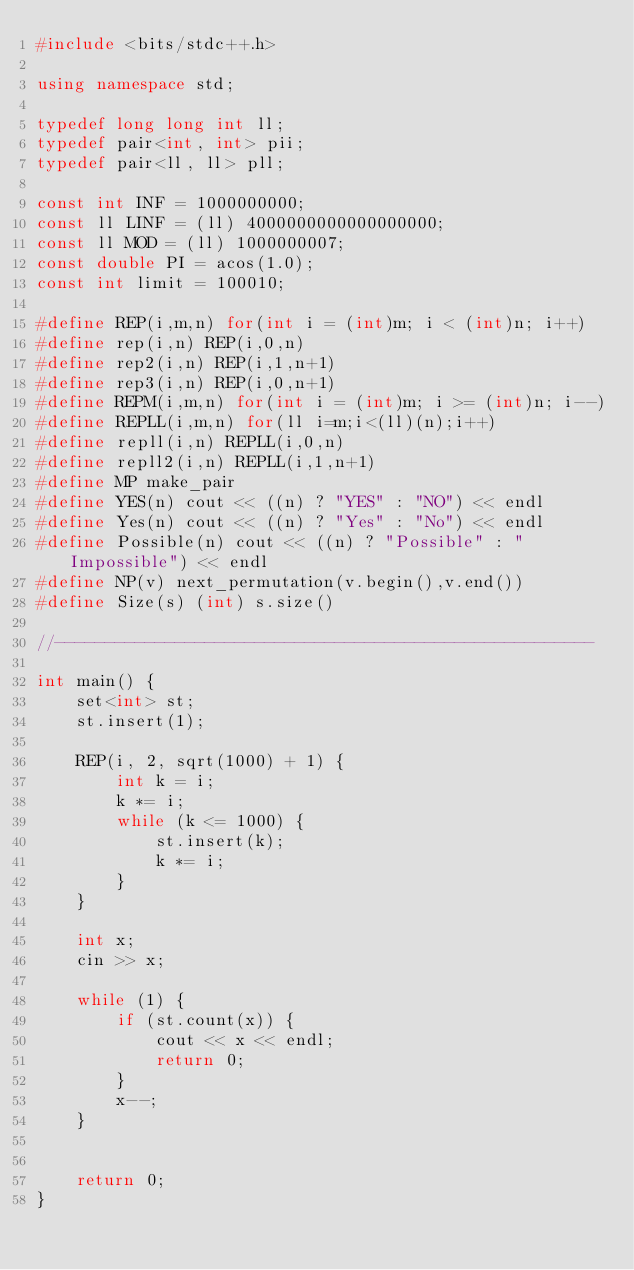Convert code to text. <code><loc_0><loc_0><loc_500><loc_500><_C++_>#include <bits/stdc++.h>

using namespace std;

typedef long long int ll;
typedef pair<int, int> pii;
typedef pair<ll, ll> pll;

const int INF = 1000000000;
const ll LINF = (ll) 4000000000000000000;
const ll MOD = (ll) 1000000007;
const double PI = acos(1.0);
const int limit = 100010;

#define REP(i,m,n) for(int i = (int)m; i < (int)n; i++)
#define rep(i,n) REP(i,0,n)
#define rep2(i,n) REP(i,1,n+1)
#define rep3(i,n) REP(i,0,n+1)
#define REPM(i,m,n) for(int i = (int)m; i >= (int)n; i--)
#define REPLL(i,m,n) for(ll i=m;i<(ll)(n);i++)
#define repll(i,n) REPLL(i,0,n)
#define repll2(i,n) REPLL(i,1,n+1)
#define MP make_pair
#define YES(n) cout << ((n) ? "YES" : "NO") << endl
#define Yes(n) cout << ((n) ? "Yes" : "No") << endl
#define Possible(n) cout << ((n) ? "Possible" : "Impossible") << endl
#define NP(v) next_permutation(v.begin(),v.end())
#define Size(s) (int) s.size()

//------------------------------------------------------

int main() {
    set<int> st;
    st.insert(1);

    REP(i, 2, sqrt(1000) + 1) {
        int k = i;
        k *= i;
        while (k <= 1000) {
            st.insert(k);
            k *= i;
        }
    }

    int x;
    cin >> x;

    while (1) {
        if (st.count(x)) {
            cout << x << endl;
            return 0;
        }
        x--;
    }


    return 0;
}
</code> 